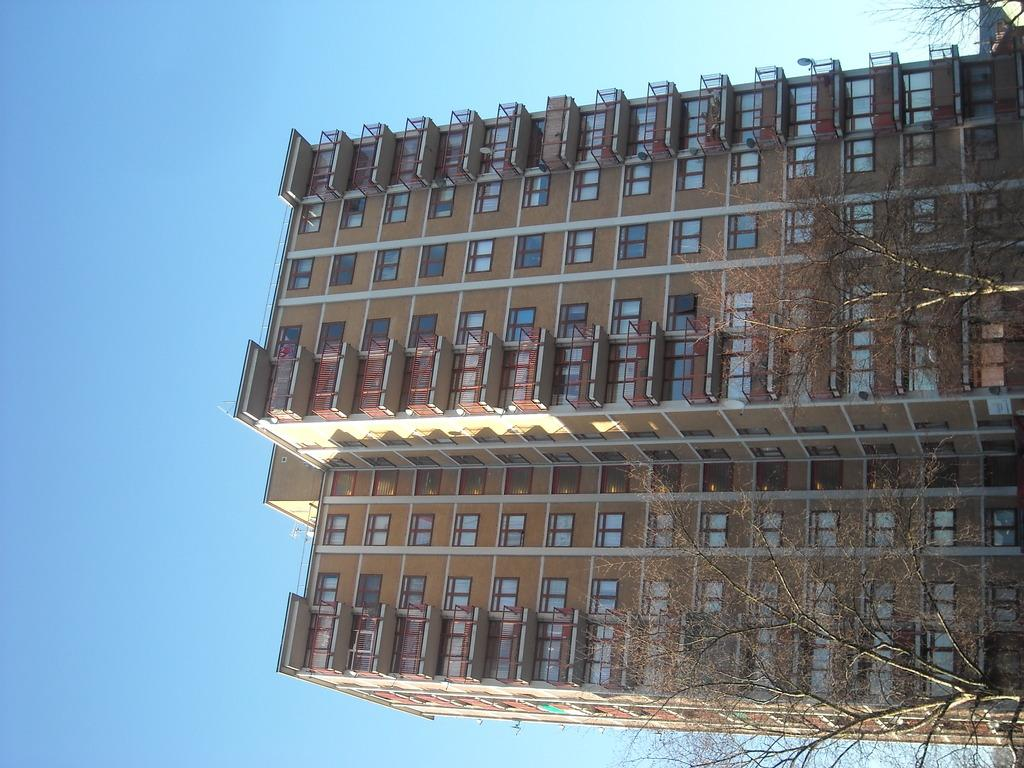How is the image oriented? The image is tilted. What is the main structure visible in the image? There is a huge building in the image. What type of vegetation is present in front of the building? There are dry trees in front of the building. What flavor of ice can be tasted in the image? There is no ice present in the image, so it cannot be tasted. 